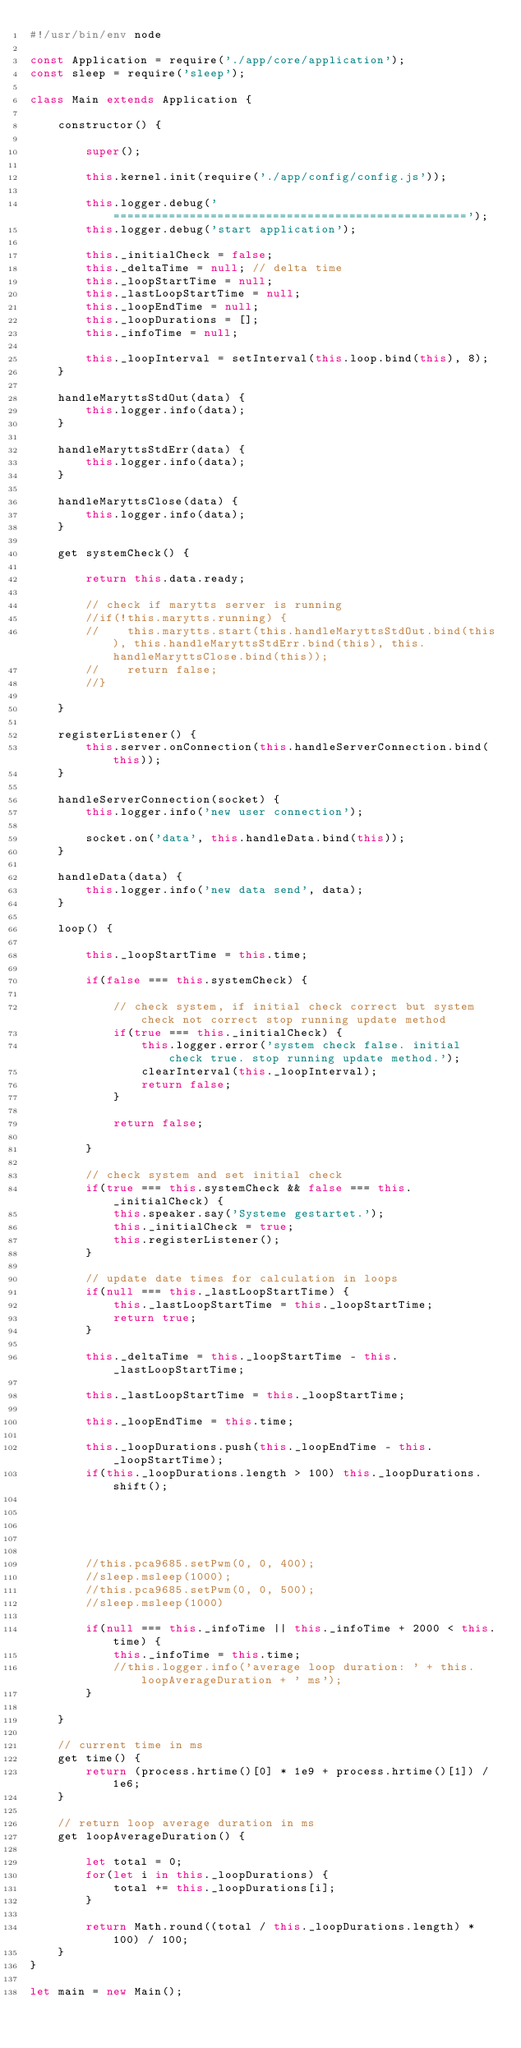<code> <loc_0><loc_0><loc_500><loc_500><_JavaScript_>#!/usr/bin/env node

const Application = require('./app/core/application');
const sleep = require('sleep');

class Main extends Application {

    constructor() {

        super();

        this.kernel.init(require('./app/config/config.js'));

        this.logger.debug('===================================================');
        this.logger.debug('start application');

        this._initialCheck = false;
        this._deltaTime = null; // delta time
        this._loopStartTime = null;
        this._lastLoopStartTime = null;
        this._loopEndTime = null;
        this._loopDurations = [];
        this._infoTime = null;

        this._loopInterval = setInterval(this.loop.bind(this), 8);
    }

    handleMaryttsStdOut(data) {
        this.logger.info(data);
    }

    handleMaryttsStdErr(data) {
        this.logger.info(data);
    }

    handleMaryttsClose(data) {
        this.logger.info(data);
    }

    get systemCheck() {

        return this.data.ready;

        // check if marytts server is running
        //if(!this.marytts.running) {
        //    this.marytts.start(this.handleMaryttsStdOut.bind(this), this.handleMaryttsStdErr.bind(this), this.handleMaryttsClose.bind(this));
        //    return false;
        //}

    }

    registerListener() {
        this.server.onConnection(this.handleServerConnection.bind(this));
    }

    handleServerConnection(socket) {
        this.logger.info('new user connection');

        socket.on('data', this.handleData.bind(this));
    }

    handleData(data) {
        this.logger.info('new data send', data);
    }

    loop() {

        this._loopStartTime = this.time;

        if(false === this.systemCheck) {

            // check system, if initial check correct but system check not correct stop running update method
            if(true === this._initialCheck) {
                this.logger.error('system check false. initial check true. stop running update method.');
                clearInterval(this._loopInterval);
                return false;
            }

            return false;

        }

        // check system and set initial check
        if(true === this.systemCheck && false === this._initialCheck) {
            this.speaker.say('Systeme gestartet.');
            this._initialCheck = true;
            this.registerListener();
        }

        // update date times for calculation in loops
        if(null === this._lastLoopStartTime) {
            this._lastLoopStartTime = this._loopStartTime;
            return true;
        }

        this._deltaTime = this._loopStartTime - this._lastLoopStartTime;

        this._lastLoopStartTime = this._loopStartTime;

        this._loopEndTime = this.time;

        this._loopDurations.push(this._loopEndTime - this._loopStartTime);
        if(this._loopDurations.length > 100) this._loopDurations.shift();





        //this.pca9685.setPwm(0, 0, 400);
        //sleep.msleep(1000);
        //this.pca9685.setPwm(0, 0, 500);
        //sleep.msleep(1000)

        if(null === this._infoTime || this._infoTime + 2000 < this.time) {
            this._infoTime = this.time;
            //this.logger.info('average loop duration: ' + this.loopAverageDuration + ' ms');
        }

    }

    // current time in ms
    get time() {
        return (process.hrtime()[0] * 1e9 + process.hrtime()[1]) / 1e6;
    }

    // return loop average duration in ms
    get loopAverageDuration() {

        let total = 0;
        for(let i in this._loopDurations) {
            total += this._loopDurations[i];
        }

        return Math.round((total / this._loopDurations.length) * 100) / 100;
    }
}

let main = new Main();</code> 